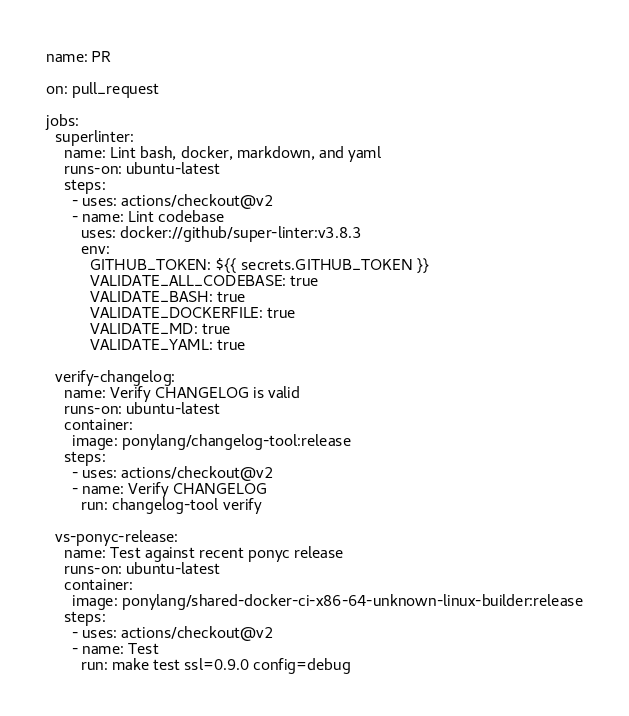<code> <loc_0><loc_0><loc_500><loc_500><_YAML_>name: PR

on: pull_request

jobs:
  superlinter:
    name: Lint bash, docker, markdown, and yaml
    runs-on: ubuntu-latest
    steps:
      - uses: actions/checkout@v2
      - name: Lint codebase
        uses: docker://github/super-linter:v3.8.3
        env:
          GITHUB_TOKEN: ${{ secrets.GITHUB_TOKEN }}
          VALIDATE_ALL_CODEBASE: true
          VALIDATE_BASH: true
          VALIDATE_DOCKERFILE: true
          VALIDATE_MD: true
          VALIDATE_YAML: true

  verify-changelog:
    name: Verify CHANGELOG is valid
    runs-on: ubuntu-latest
    container:
      image: ponylang/changelog-tool:release
    steps:
      - uses: actions/checkout@v2
      - name: Verify CHANGELOG
        run: changelog-tool verify

  vs-ponyc-release:
    name: Test against recent ponyc release
    runs-on: ubuntu-latest
    container:
      image: ponylang/shared-docker-ci-x86-64-unknown-linux-builder:release
    steps:
      - uses: actions/checkout@v2
      - name: Test
        run: make test ssl=0.9.0 config=debug
</code> 